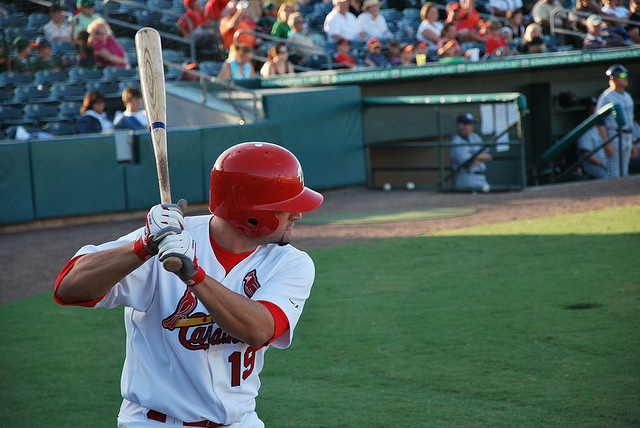Describe the objects in this image and their specific colors. I can see people in black, maroon, and lightblue tones, people in black, gray, blue, and darkblue tones, baseball bat in black, darkgray, lightgray, and gray tones, people in black, gray, and blue tones, and people in black, blue, and gray tones in this image. 